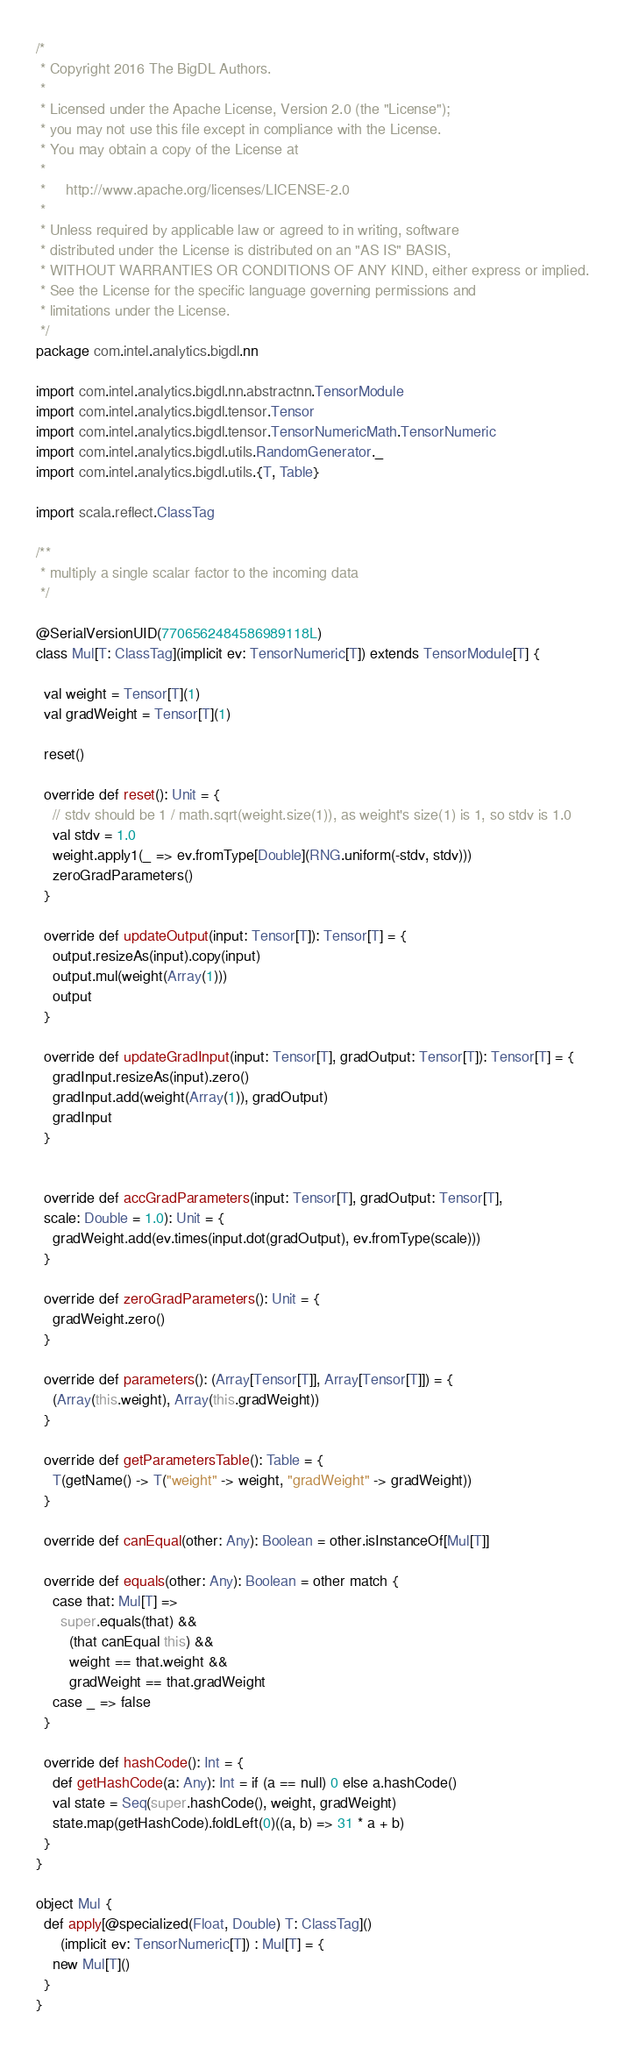Convert code to text. <code><loc_0><loc_0><loc_500><loc_500><_Scala_>/*
 * Copyright 2016 The BigDL Authors.
 *
 * Licensed under the Apache License, Version 2.0 (the "License");
 * you may not use this file except in compliance with the License.
 * You may obtain a copy of the License at
 *
 *     http://www.apache.org/licenses/LICENSE-2.0
 *
 * Unless required by applicable law or agreed to in writing, software
 * distributed under the License is distributed on an "AS IS" BASIS,
 * WITHOUT WARRANTIES OR CONDITIONS OF ANY KIND, either express or implied.
 * See the License for the specific language governing permissions and
 * limitations under the License.
 */
package com.intel.analytics.bigdl.nn

import com.intel.analytics.bigdl.nn.abstractnn.TensorModule
import com.intel.analytics.bigdl.tensor.Tensor
import com.intel.analytics.bigdl.tensor.TensorNumericMath.TensorNumeric
import com.intel.analytics.bigdl.utils.RandomGenerator._
import com.intel.analytics.bigdl.utils.{T, Table}

import scala.reflect.ClassTag

/**
 * multiply a single scalar factor to the incoming data
 */

@SerialVersionUID(7706562484586989118L)
class Mul[T: ClassTag](implicit ev: TensorNumeric[T]) extends TensorModule[T] {

  val weight = Tensor[T](1)
  val gradWeight = Tensor[T](1)

  reset()

  override def reset(): Unit = {
    // stdv should be 1 / math.sqrt(weight.size(1)), as weight's size(1) is 1, so stdv is 1.0
    val stdv = 1.0
    weight.apply1(_ => ev.fromType[Double](RNG.uniform(-stdv, stdv)))
    zeroGradParameters()
  }

  override def updateOutput(input: Tensor[T]): Tensor[T] = {
    output.resizeAs(input).copy(input)
    output.mul(weight(Array(1)))
    output
  }

  override def updateGradInput(input: Tensor[T], gradOutput: Tensor[T]): Tensor[T] = {
    gradInput.resizeAs(input).zero()
    gradInput.add(weight(Array(1)), gradOutput)
    gradInput
  }


  override def accGradParameters(input: Tensor[T], gradOutput: Tensor[T],
  scale: Double = 1.0): Unit = {
    gradWeight.add(ev.times(input.dot(gradOutput), ev.fromType(scale)))
  }

  override def zeroGradParameters(): Unit = {
    gradWeight.zero()
  }

  override def parameters(): (Array[Tensor[T]], Array[Tensor[T]]) = {
    (Array(this.weight), Array(this.gradWeight))
  }

  override def getParametersTable(): Table = {
    T(getName() -> T("weight" -> weight, "gradWeight" -> gradWeight))
  }

  override def canEqual(other: Any): Boolean = other.isInstanceOf[Mul[T]]

  override def equals(other: Any): Boolean = other match {
    case that: Mul[T] =>
      super.equals(that) &&
        (that canEqual this) &&
        weight == that.weight &&
        gradWeight == that.gradWeight
    case _ => false
  }

  override def hashCode(): Int = {
    def getHashCode(a: Any): Int = if (a == null) 0 else a.hashCode()
    val state = Seq(super.hashCode(), weight, gradWeight)
    state.map(getHashCode).foldLeft(0)((a, b) => 31 * a + b)
  }
}

object Mul {
  def apply[@specialized(Float, Double) T: ClassTag]()
      (implicit ev: TensorNumeric[T]) : Mul[T] = {
    new Mul[T]()
  }
}
</code> 